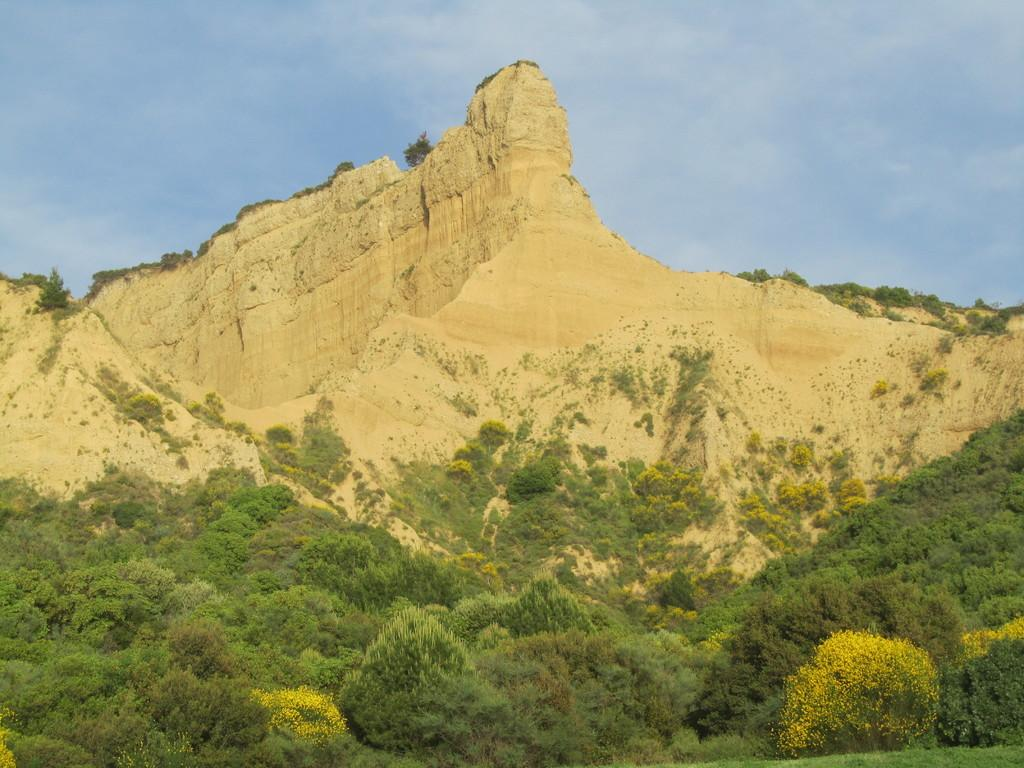What type of natural features can be seen in the image? There are trees and mountains in the image. What part of the natural environment is visible in the image? The sky is visible in the image. What type of whip can be seen in the image? There is no whip present in the image. How does the image provide comfort to the viewer? The image itself does not provide comfort to the viewer; it is a visual representation of natural features. 